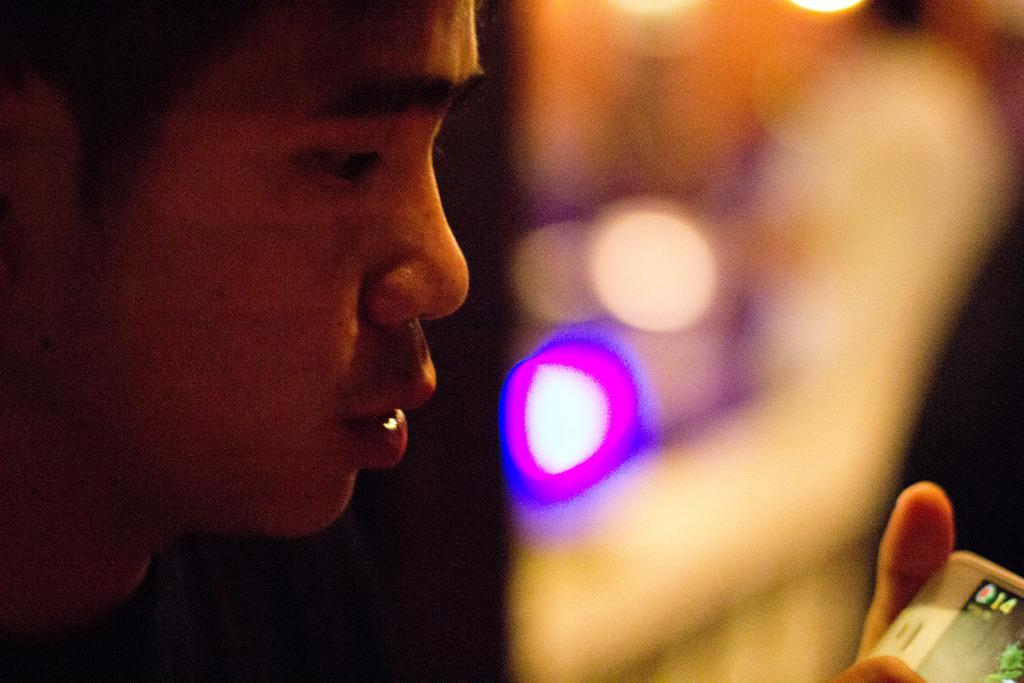Who is present in the image? There is a man in the image. What part of the man's body is visible in the image? Fingers are visible in the image. Can you describe the background of the image? The background of the image is blurred and colorful. What country is the man traveling to in the image? There is no indication of the man traveling to a specific country in the image. 